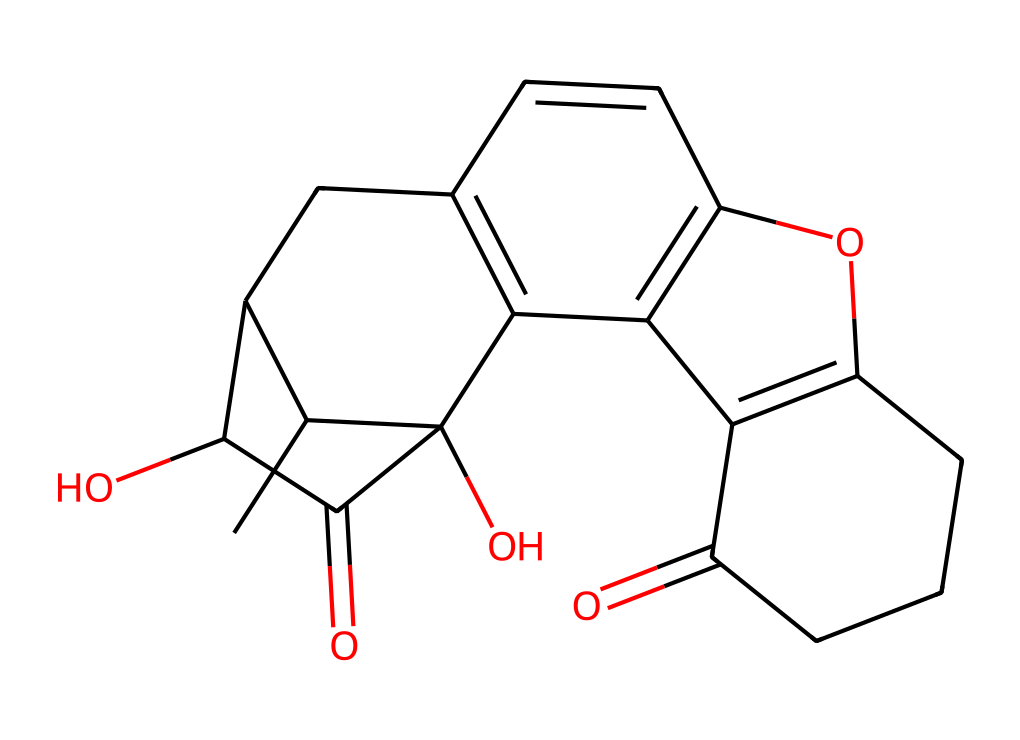What is the molecular formula of naloxone? To derive the molecular formula, count the number of each type of atom represented in the SMILES notation: carbon (C), hydrogen (H), and oxygen (O). The analysis indicates that there are 17 carbons, 19 hydrogens, and 2 oxygens. Thus, the molecular formula can be written as C17H19O2.
Answer: C17H19O2 How many rings are present in the structure of naloxone? Analyze the structure depicted by the SMILES representation, identifying the cyclic portions. In this case, there are four prominent rings formed by the arrangement of carbon atoms. Counting these yields a total of four rings in the structure.
Answer: 4 What type of chemical bonding is primarily present in naloxone? Focus on the prevalent bonding in the structure, which consists mainly of covalent bonds due to the sharing of electrons among the carbon, hydrogen, and oxygen atoms. Since organic compounds like naloxone typically involve the sharing of electrons to form stable connections, the primary type of bonding is covalent.
Answer: covalent Which functional groups are identified in naloxone? Examine the SMILES representation to identify the distinctive functional groups by looking for specific patterns. Naloxone contains a hydroxyl group (indicated by -OH) and carbonyl groups (indicated by C=O), which classify it as an alcohol and a ketone. Thus, naloxone features both hydroxyl (-OH) and carbonyl (C=O) functional groups.
Answer: hydroxyl and carbonyl How does the molecular structure of naloxone contribute to its antagonist properties? Consider the arrangement of atoms and the specific types of bonds in the structure that allow naloxone to fit into opioid receptors, blocking the effects of opioids. Its structure allows it to effectively compete with opioids for binding sites without activating the receptors, hence its role as an antagonist. This is due to the specific molecular interactions facilitated by its functional groups and overall configuration.
Answer: blocks opioid receptors What makes naloxone an effective emergency treatment for opioid overdoses? Assess the molecular structure and its interactions at the biological level. Naloxone’s structural features enable it to displace opioids from their receptors and rapidly counteract the effects of overdose, restoring normal breathing and consciousness. This rapid binding and competition with existing opioids make it effective in emergencies.
Answer: rapid binding to receptors 